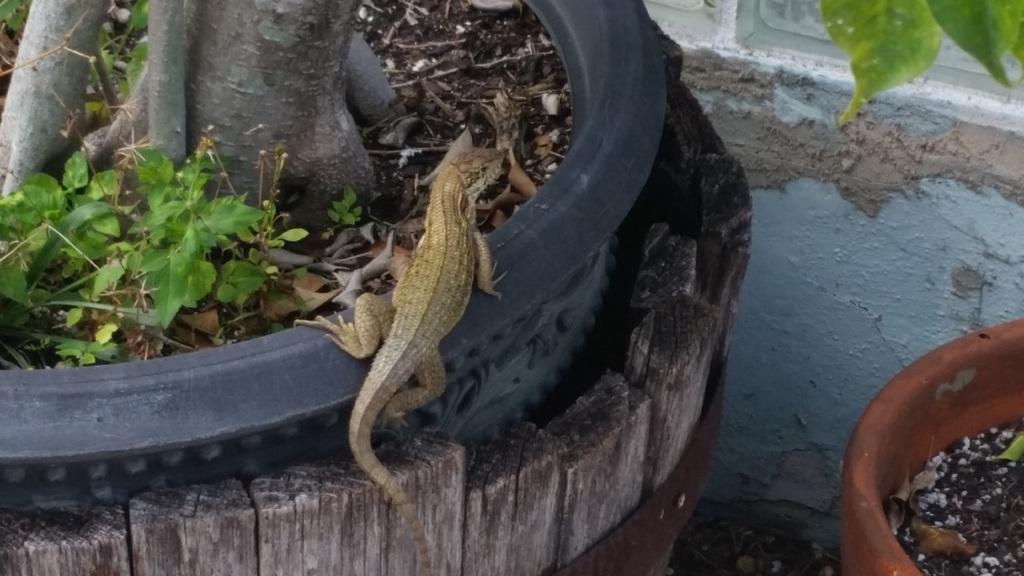Can you describe this image briefly? In this picture I can see lizard on the pot, side I can see one more pot with some plants. 